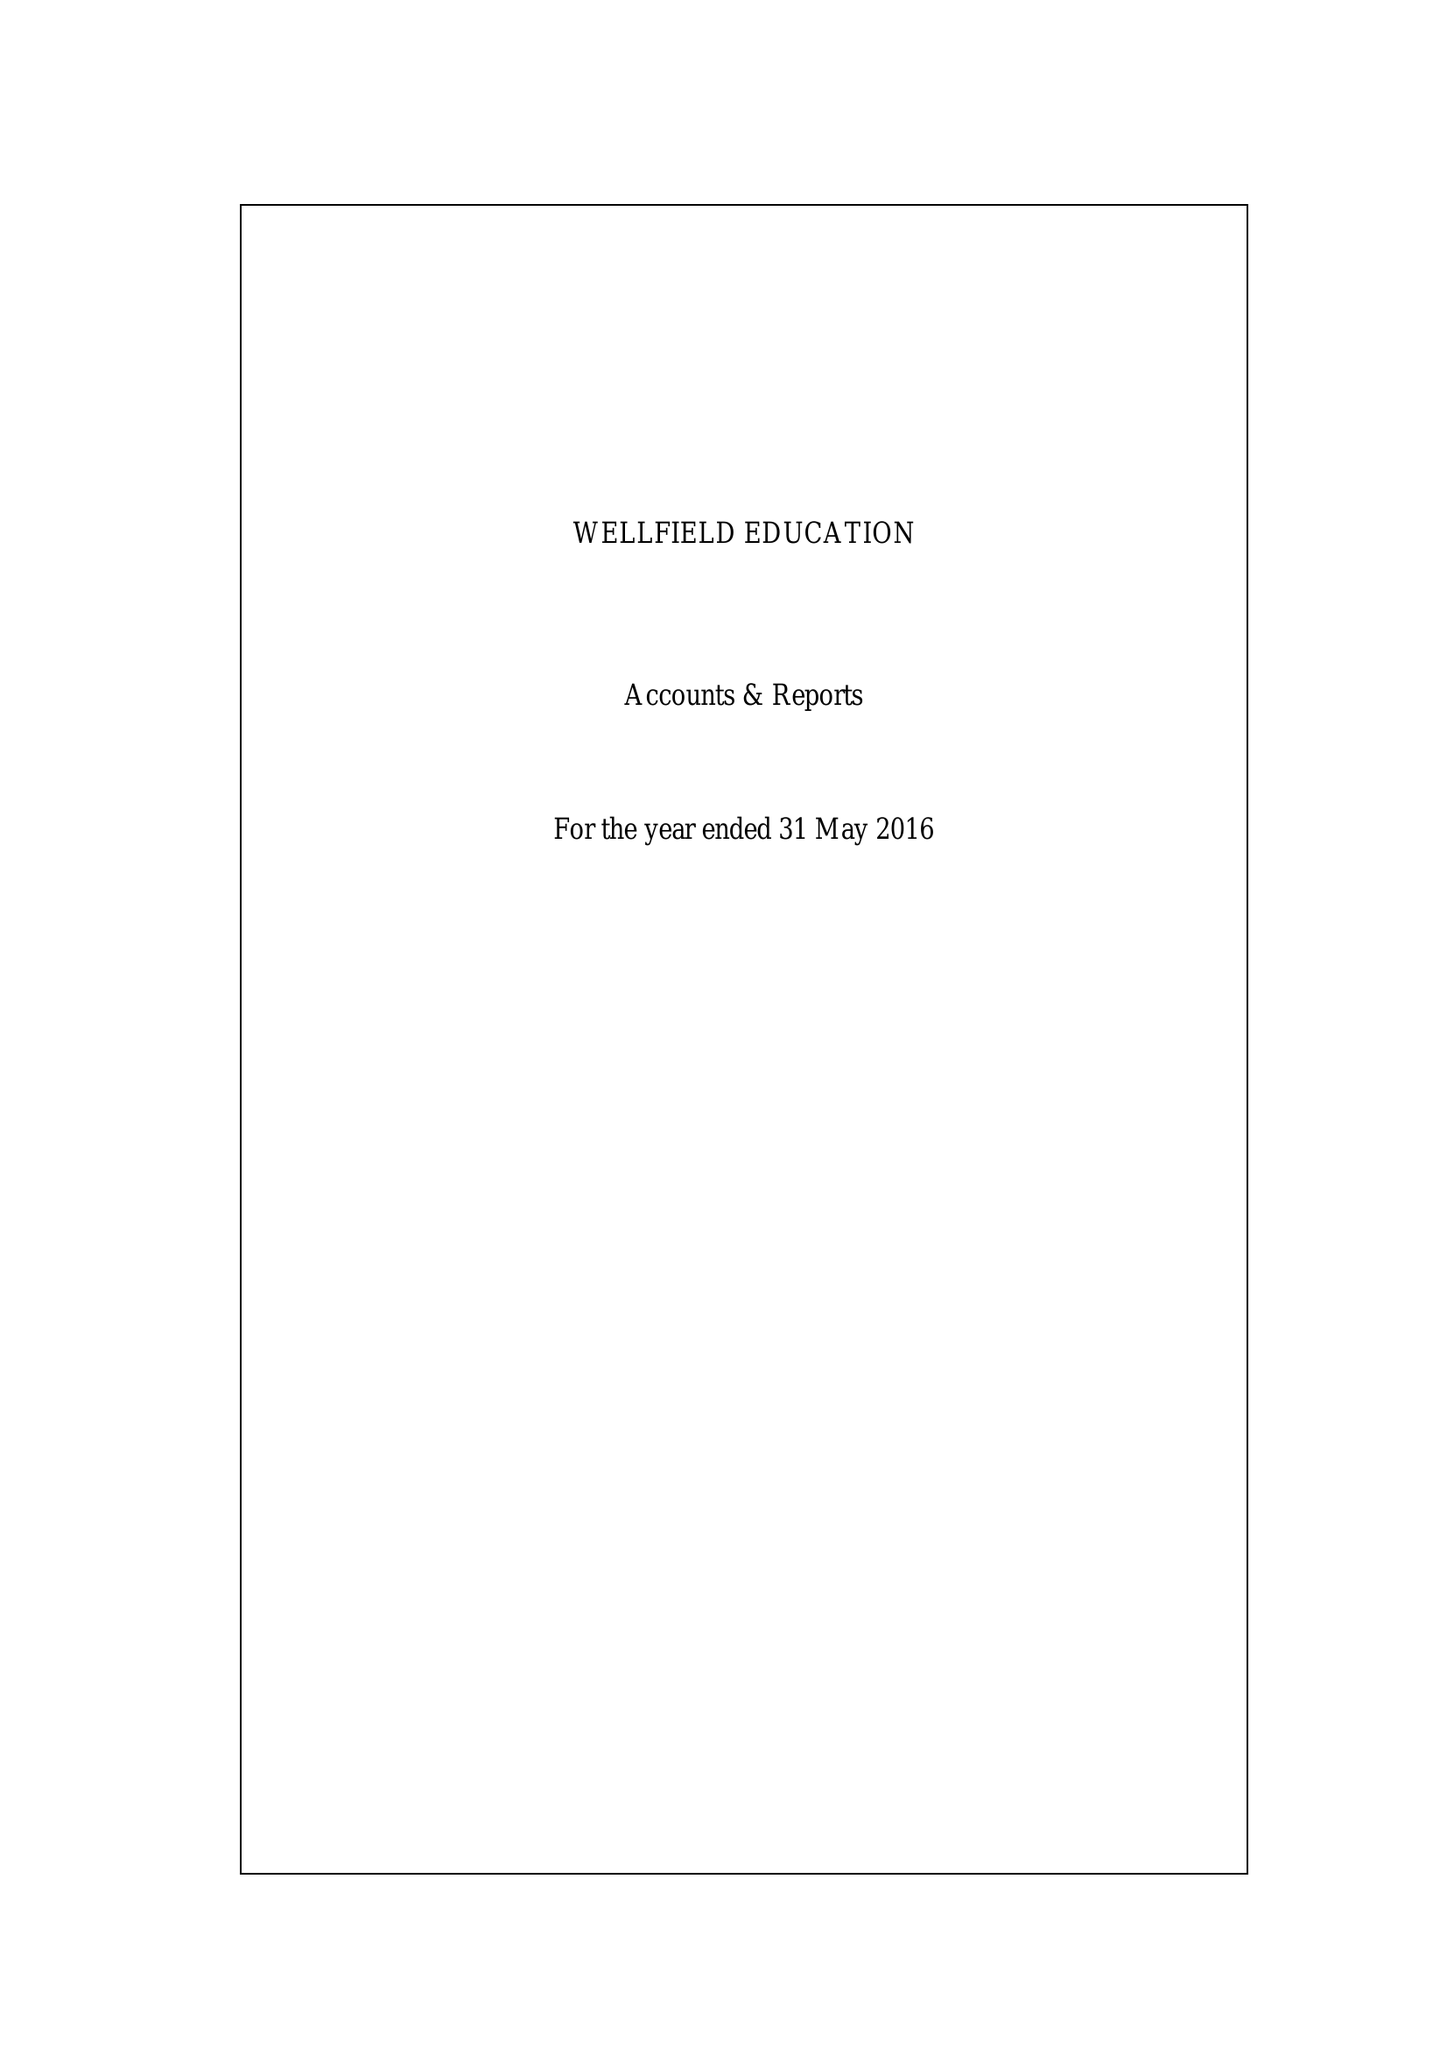What is the value for the address__post_town?
Answer the question using a single word or phrase. LONDON 